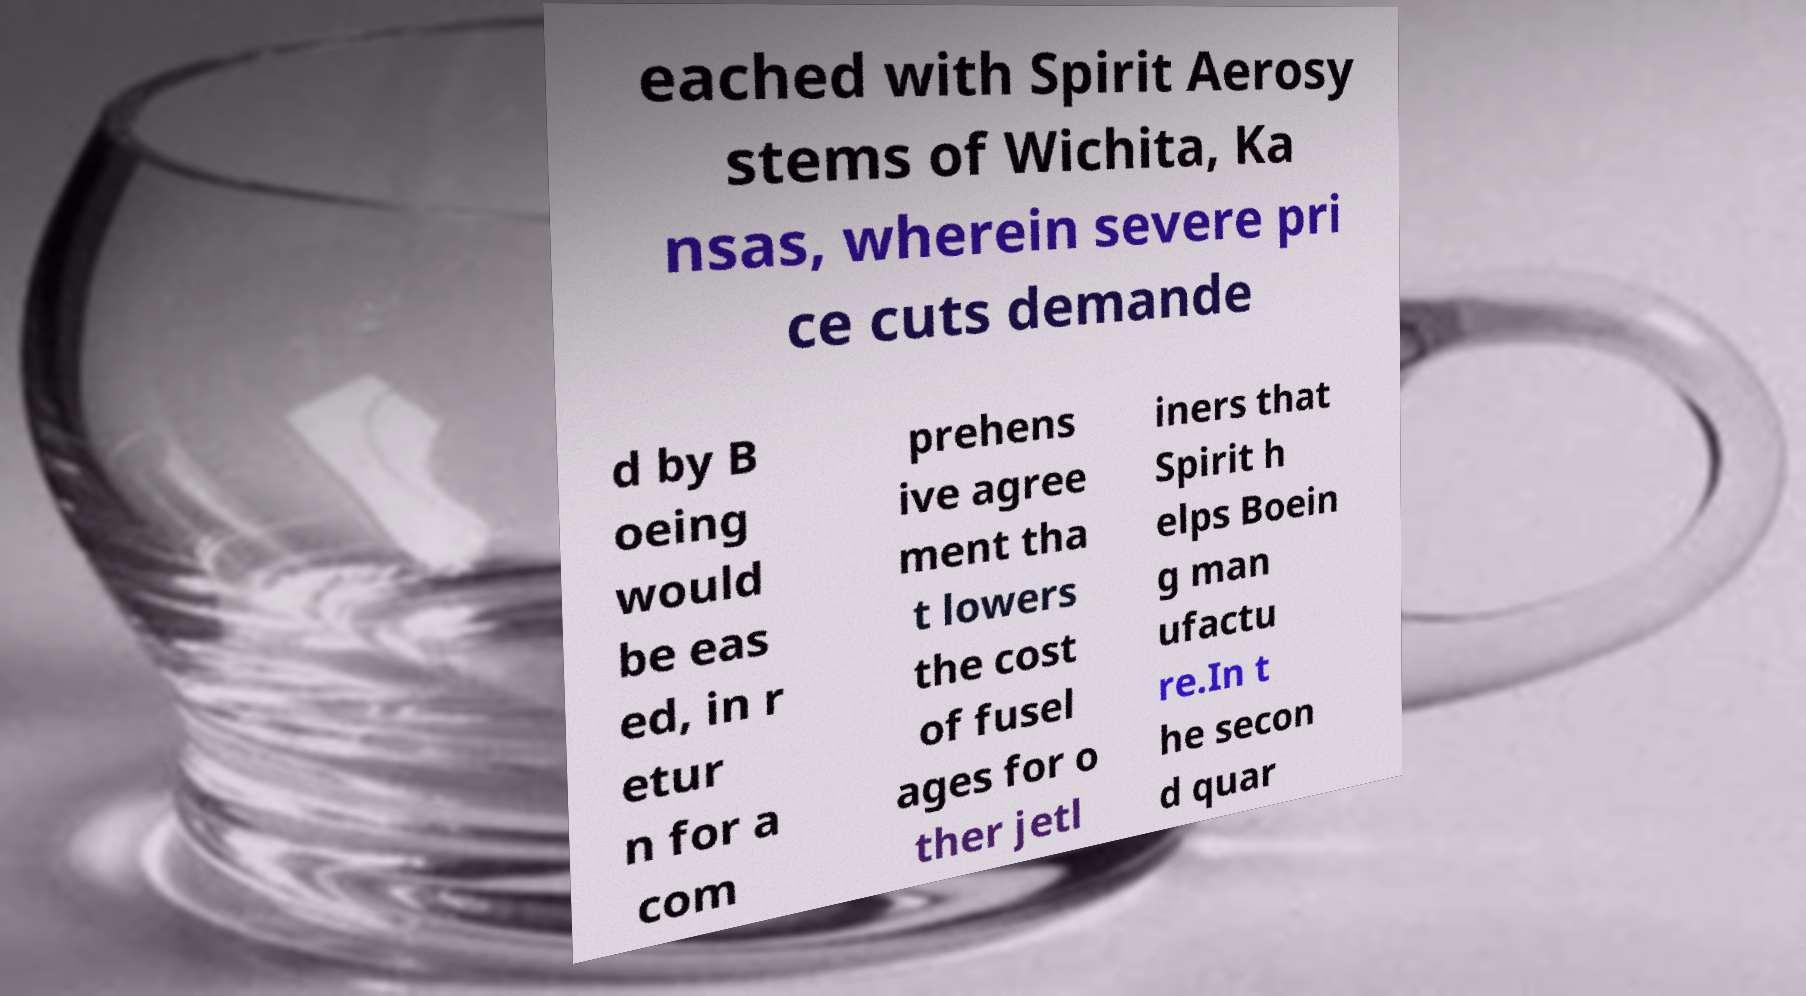For documentation purposes, I need the text within this image transcribed. Could you provide that? eached with Spirit Aerosy stems of Wichita, Ka nsas, wherein severe pri ce cuts demande d by B oeing would be eas ed, in r etur n for a com prehens ive agree ment tha t lowers the cost of fusel ages for o ther jetl iners that Spirit h elps Boein g man ufactu re.In t he secon d quar 